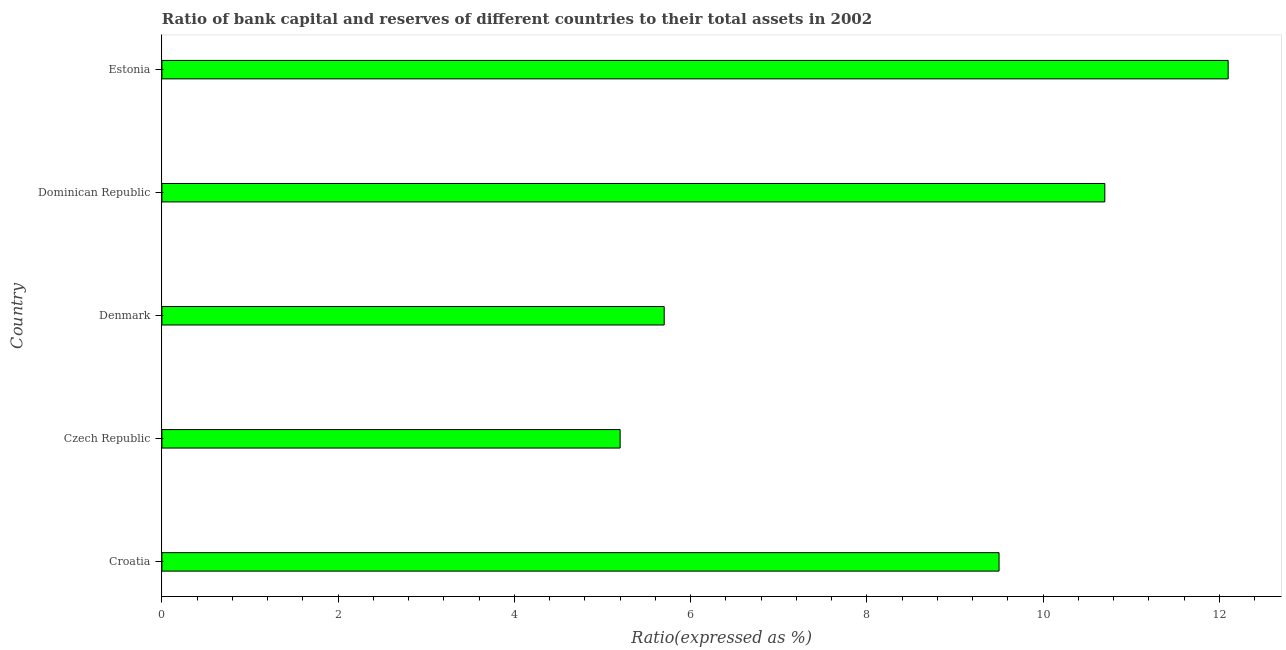Does the graph contain grids?
Provide a short and direct response. No. What is the title of the graph?
Provide a succinct answer. Ratio of bank capital and reserves of different countries to their total assets in 2002. What is the label or title of the X-axis?
Ensure brevity in your answer.  Ratio(expressed as %). What is the bank capital to assets ratio in Dominican Republic?
Keep it short and to the point. 10.7. Across all countries, what is the maximum bank capital to assets ratio?
Your response must be concise. 12.1. Across all countries, what is the minimum bank capital to assets ratio?
Ensure brevity in your answer.  5.2. In which country was the bank capital to assets ratio maximum?
Make the answer very short. Estonia. In which country was the bank capital to assets ratio minimum?
Provide a short and direct response. Czech Republic. What is the sum of the bank capital to assets ratio?
Make the answer very short. 43.2. What is the difference between the bank capital to assets ratio in Croatia and Estonia?
Your answer should be very brief. -2.6. What is the average bank capital to assets ratio per country?
Make the answer very short. 8.64. What is the median bank capital to assets ratio?
Give a very brief answer. 9.5. In how many countries, is the bank capital to assets ratio greater than 8.8 %?
Your answer should be compact. 3. What is the ratio of the bank capital to assets ratio in Croatia to that in Estonia?
Offer a terse response. 0.79. Is the sum of the bank capital to assets ratio in Croatia and Estonia greater than the maximum bank capital to assets ratio across all countries?
Your answer should be very brief. Yes. In how many countries, is the bank capital to assets ratio greater than the average bank capital to assets ratio taken over all countries?
Your response must be concise. 3. How many bars are there?
Your response must be concise. 5. Are all the bars in the graph horizontal?
Your answer should be compact. Yes. What is the difference between two consecutive major ticks on the X-axis?
Your answer should be very brief. 2. Are the values on the major ticks of X-axis written in scientific E-notation?
Your response must be concise. No. What is the Ratio(expressed as %) of Croatia?
Keep it short and to the point. 9.5. What is the Ratio(expressed as %) in Estonia?
Your response must be concise. 12.1. What is the difference between the Ratio(expressed as %) in Croatia and Dominican Republic?
Your answer should be very brief. -1.2. What is the difference between the Ratio(expressed as %) in Croatia and Estonia?
Provide a succinct answer. -2.6. What is the difference between the Ratio(expressed as %) in Czech Republic and Dominican Republic?
Your answer should be compact. -5.5. What is the difference between the Ratio(expressed as %) in Denmark and Dominican Republic?
Give a very brief answer. -5. What is the difference between the Ratio(expressed as %) in Denmark and Estonia?
Your response must be concise. -6.4. What is the ratio of the Ratio(expressed as %) in Croatia to that in Czech Republic?
Provide a short and direct response. 1.83. What is the ratio of the Ratio(expressed as %) in Croatia to that in Denmark?
Make the answer very short. 1.67. What is the ratio of the Ratio(expressed as %) in Croatia to that in Dominican Republic?
Your answer should be very brief. 0.89. What is the ratio of the Ratio(expressed as %) in Croatia to that in Estonia?
Your answer should be compact. 0.79. What is the ratio of the Ratio(expressed as %) in Czech Republic to that in Denmark?
Your answer should be very brief. 0.91. What is the ratio of the Ratio(expressed as %) in Czech Republic to that in Dominican Republic?
Ensure brevity in your answer.  0.49. What is the ratio of the Ratio(expressed as %) in Czech Republic to that in Estonia?
Ensure brevity in your answer.  0.43. What is the ratio of the Ratio(expressed as %) in Denmark to that in Dominican Republic?
Give a very brief answer. 0.53. What is the ratio of the Ratio(expressed as %) in Denmark to that in Estonia?
Offer a terse response. 0.47. What is the ratio of the Ratio(expressed as %) in Dominican Republic to that in Estonia?
Keep it short and to the point. 0.88. 